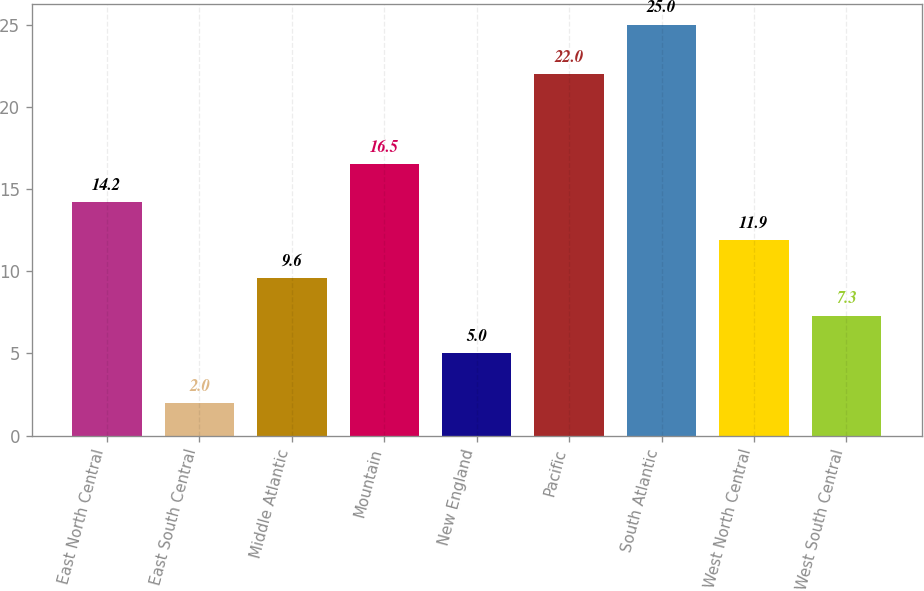Convert chart. <chart><loc_0><loc_0><loc_500><loc_500><bar_chart><fcel>East North Central<fcel>East South Central<fcel>Middle Atlantic<fcel>Mountain<fcel>New England<fcel>Pacific<fcel>South Atlantic<fcel>West North Central<fcel>West South Central<nl><fcel>14.2<fcel>2<fcel>9.6<fcel>16.5<fcel>5<fcel>22<fcel>25<fcel>11.9<fcel>7.3<nl></chart> 